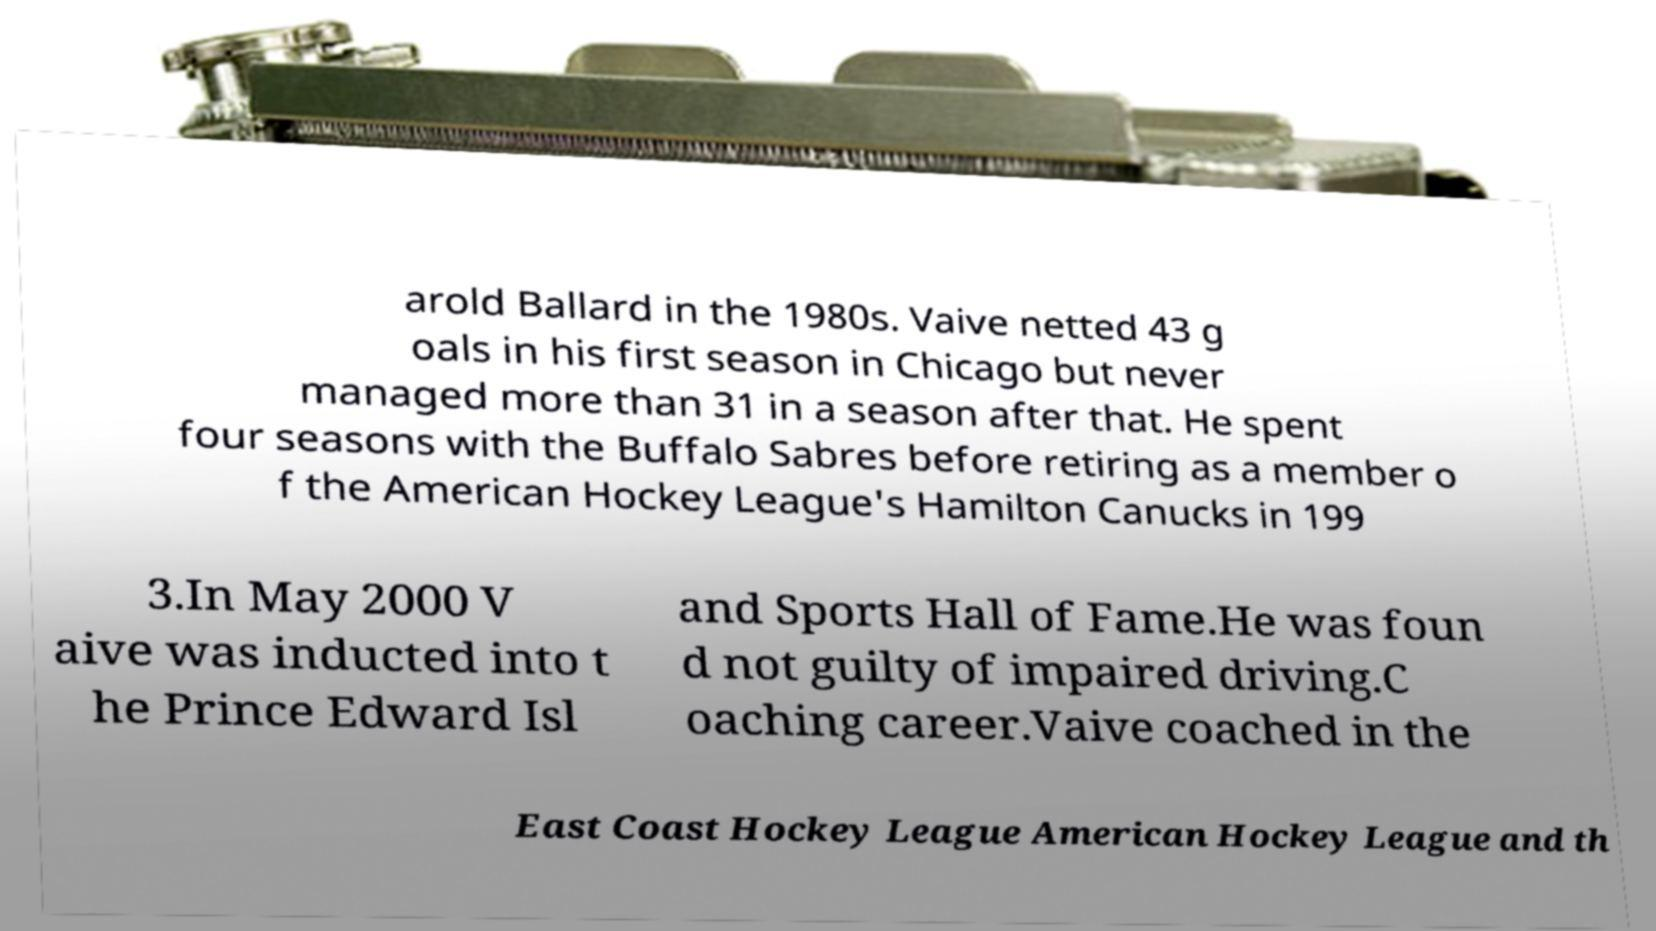What messages or text are displayed in this image? I need them in a readable, typed format. arold Ballard in the 1980s. Vaive netted 43 g oals in his first season in Chicago but never managed more than 31 in a season after that. He spent four seasons with the Buffalo Sabres before retiring as a member o f the American Hockey League's Hamilton Canucks in 199 3.In May 2000 V aive was inducted into t he Prince Edward Isl and Sports Hall of Fame.He was foun d not guilty of impaired driving.C oaching career.Vaive coached in the East Coast Hockey League American Hockey League and th 